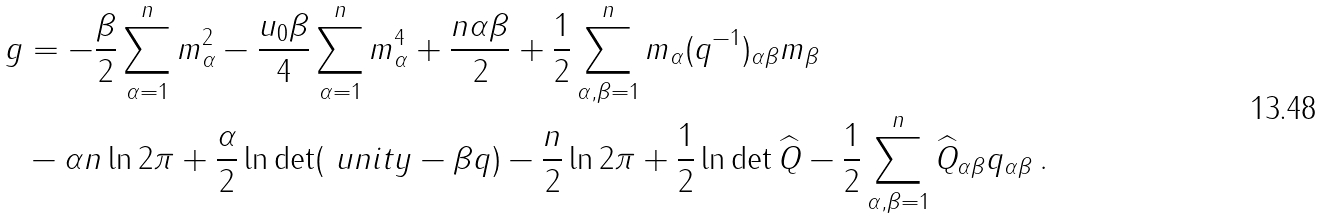<formula> <loc_0><loc_0><loc_500><loc_500>g & = - \frac { \beta } { 2 } \sum _ { \alpha = 1 } ^ { n } m _ { \alpha } ^ { 2 } - \frac { u _ { 0 } \beta } { 4 } \sum _ { \alpha = 1 } ^ { n } m _ { \alpha } ^ { 4 } + \frac { n \alpha \beta } { 2 } + \frac { 1 } { 2 } \sum _ { \alpha , \beta = 1 } ^ { n } m _ { \alpha } ( q ^ { - 1 } ) _ { \alpha \beta } m _ { \beta } \\ & - \alpha n \ln 2 \pi + \frac { \alpha } { 2 } \ln \det ( { \ u n i t y - \beta { q } } ) - \frac { n } { 2 } \ln 2 \pi + \frac { 1 } { 2 } \ln \det \widehat { Q } - \frac { 1 } { 2 } \sum _ { \alpha , \beta = 1 } ^ { n } \widehat { Q } _ { \alpha \beta } q _ { \alpha \beta } \, .</formula> 